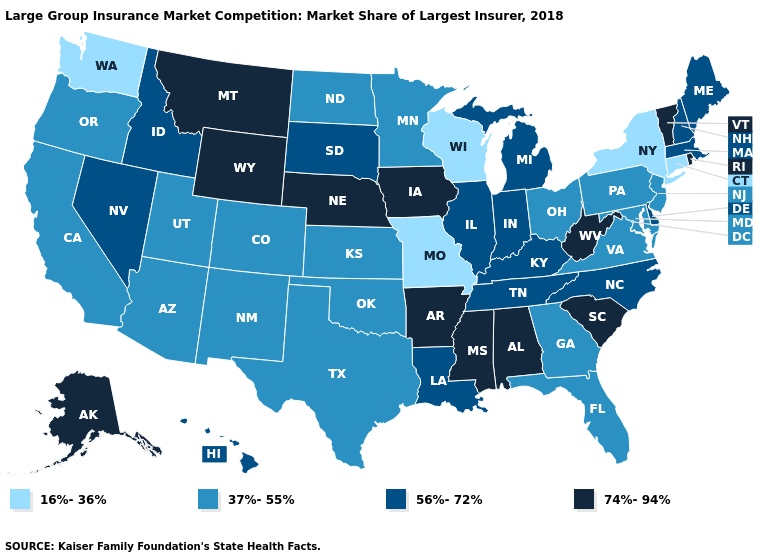What is the lowest value in states that border Maryland?
Be succinct. 37%-55%. Does Hawaii have the same value as Massachusetts?
Be succinct. Yes. Among the states that border Virginia , which have the lowest value?
Quick response, please. Maryland. Does South Dakota have the highest value in the USA?
Answer briefly. No. What is the value of South Dakota?
Write a very short answer. 56%-72%. Which states have the lowest value in the West?
Concise answer only. Washington. Does South Carolina have the highest value in the South?
Concise answer only. Yes. Name the states that have a value in the range 56%-72%?
Be succinct. Delaware, Hawaii, Idaho, Illinois, Indiana, Kentucky, Louisiana, Maine, Massachusetts, Michigan, Nevada, New Hampshire, North Carolina, South Dakota, Tennessee. Does the first symbol in the legend represent the smallest category?
Give a very brief answer. Yes. Name the states that have a value in the range 16%-36%?
Be succinct. Connecticut, Missouri, New York, Washington, Wisconsin. What is the highest value in states that border Louisiana?
Write a very short answer. 74%-94%. What is the highest value in the USA?
Be succinct. 74%-94%. What is the lowest value in the Northeast?
Write a very short answer. 16%-36%. 